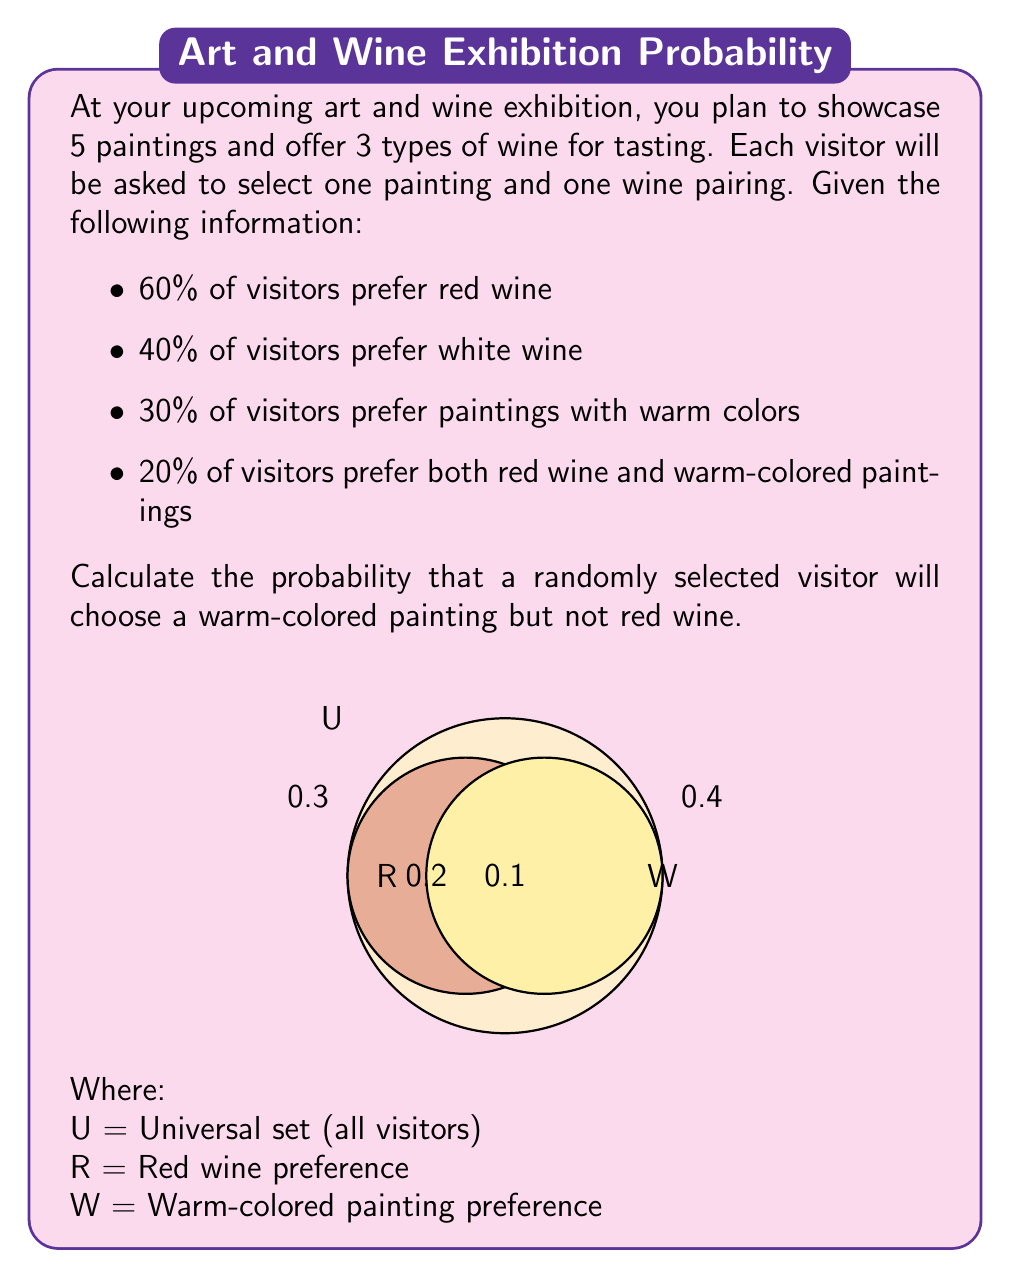Give your solution to this math problem. Let's approach this step-by-step using set theory:

1) First, let's define our sets:
   R = Set of visitors who prefer red wine
   W = Set of visitors who prefer warm-colored paintings

2) Given information:
   P(R) = 0.6 (60% prefer red wine)
   P(W) = 0.3 (30% prefer warm-colored paintings)
   P(R ∩ W) = 0.2 (20% prefer both red wine and warm-colored paintings)

3) We need to find P(W ∩ R'), which represents the probability of choosing a warm-colored painting but not red wine.

4) We can use the formula:
   P(W ∩ R') = P(W) - P(W ∩ R)

5) We already know P(W) = 0.3 and P(W ∩ R) = 0.2

6) Substituting these values:
   P(W ∩ R') = 0.3 - 0.2 = 0.1

Therefore, the probability that a randomly selected visitor will choose a warm-colored painting but not red wine is 0.1 or 10%.
Answer: 0.1 